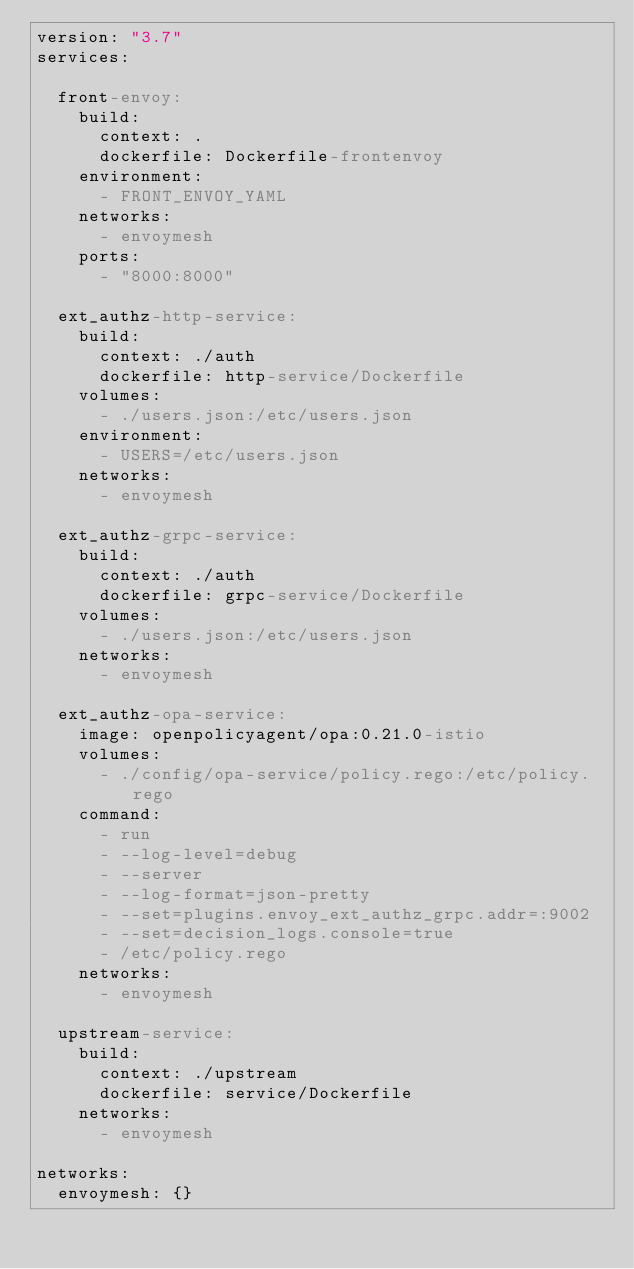<code> <loc_0><loc_0><loc_500><loc_500><_YAML_>version: "3.7"
services:

  front-envoy:
    build:
      context: .
      dockerfile: Dockerfile-frontenvoy
    environment:
      - FRONT_ENVOY_YAML
    networks:
      - envoymesh
    ports:
      - "8000:8000"

  ext_authz-http-service:
    build:
      context: ./auth
      dockerfile: http-service/Dockerfile
    volumes:
      - ./users.json:/etc/users.json
    environment:
      - USERS=/etc/users.json
    networks:
      - envoymesh

  ext_authz-grpc-service:
    build:
      context: ./auth
      dockerfile: grpc-service/Dockerfile
    volumes:
      - ./users.json:/etc/users.json
    networks:
      - envoymesh

  ext_authz-opa-service:
    image: openpolicyagent/opa:0.21.0-istio
    volumes:
      - ./config/opa-service/policy.rego:/etc/policy.rego
    command:
      - run
      - --log-level=debug
      - --server
      - --log-format=json-pretty
      - --set=plugins.envoy_ext_authz_grpc.addr=:9002
      - --set=decision_logs.console=true
      - /etc/policy.rego
    networks:
      - envoymesh

  upstream-service:
    build:
      context: ./upstream
      dockerfile: service/Dockerfile
    networks:
      - envoymesh

networks:
  envoymesh: {}
</code> 